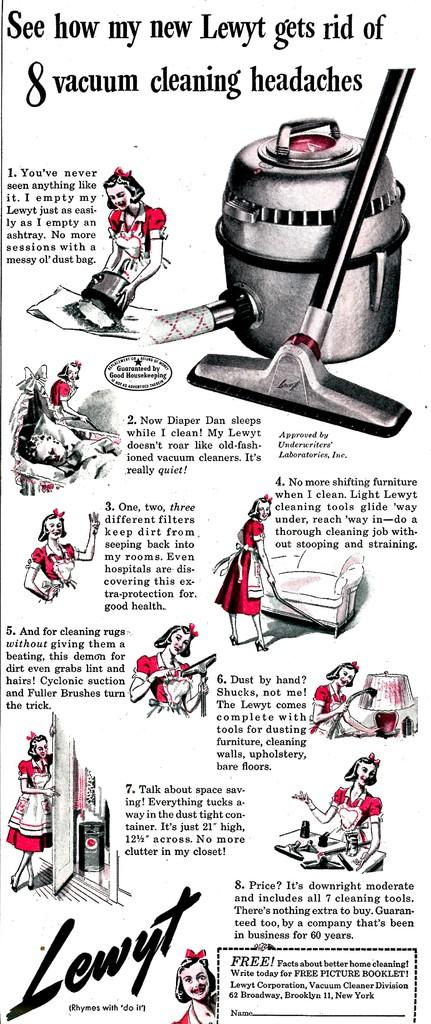Provide a one-sentence caption for the provided image. A old advertisement that shows how to use a vacuum cleaner. 